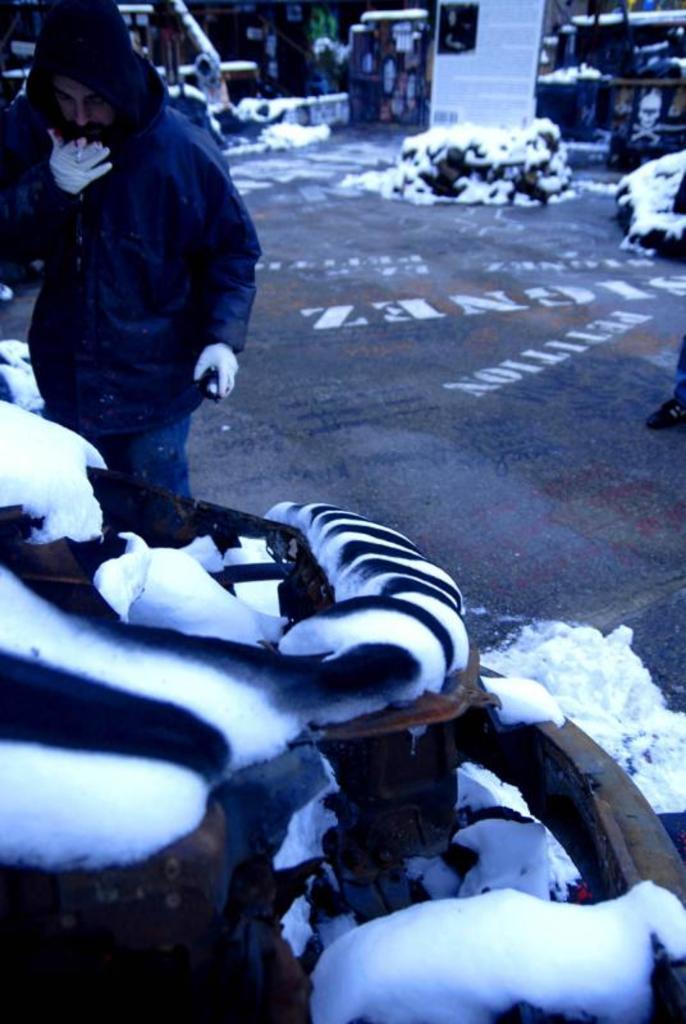Could you give a brief overview of what you see in this image? On the left side of the image we can see a person holding a cigarette and graffiti bottle. At the bottom of the image we can see snow and some objects. In the background we can see road, building, snow and some objects. 